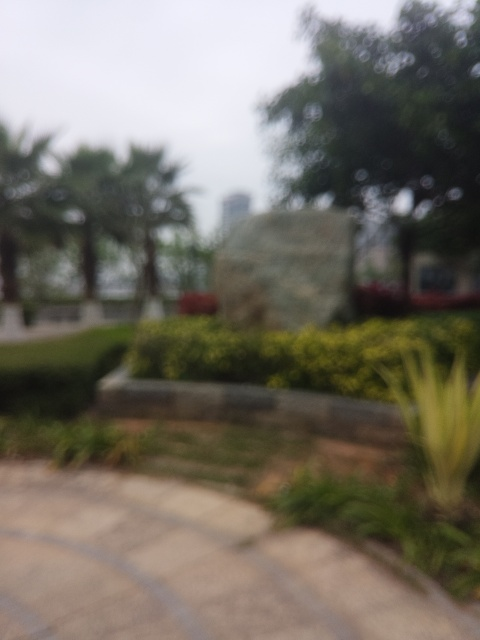What are some artifacts present in the image?
A. Color artifacts
B. Slight noise artifacts
C. Vibrant artifacts Although it is challenging to assess the specifics given the image's overall blurriness, the most noticeable artifact is the image's lack of sharpness, which could be classified as 'B. Slight noise artifacts'. The lack of clarity might result from camera shake, incorrect focus, or a low-quality camera sensor. Moreover, there are no signs of miscoloration that would indicate color artifacts, and the vibrancy seems to be affected primarily by the blurriness, so we cannot confidently consider it a vibrancy artifact. 